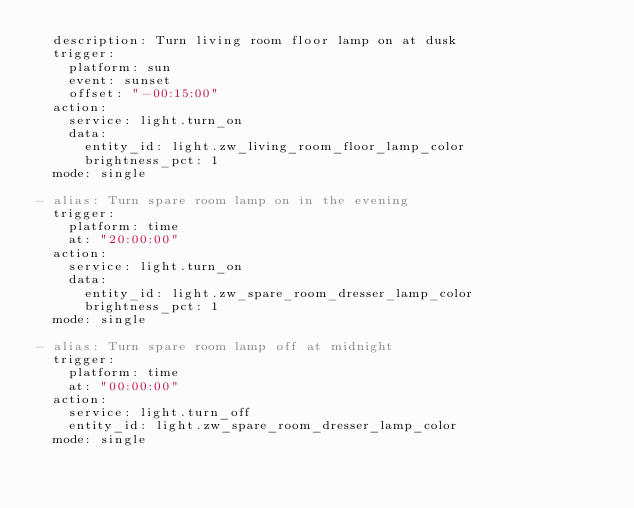<code> <loc_0><loc_0><loc_500><loc_500><_YAML_>  description: Turn living room floor lamp on at dusk
  trigger:
    platform: sun
    event: sunset
    offset: "-00:15:00"
  action:
    service: light.turn_on
    data:
      entity_id: light.zw_living_room_floor_lamp_color
      brightness_pct: 1
  mode: single

- alias: Turn spare room lamp on in the evening
  trigger:
    platform: time
    at: "20:00:00"
  action:
    service: light.turn_on
    data:
      entity_id: light.zw_spare_room_dresser_lamp_color
      brightness_pct: 1
  mode: single

- alias: Turn spare room lamp off at midnight
  trigger:
    platform: time
    at: "00:00:00"
  action:
    service: light.turn_off
    entity_id: light.zw_spare_room_dresser_lamp_color
  mode: single

</code> 